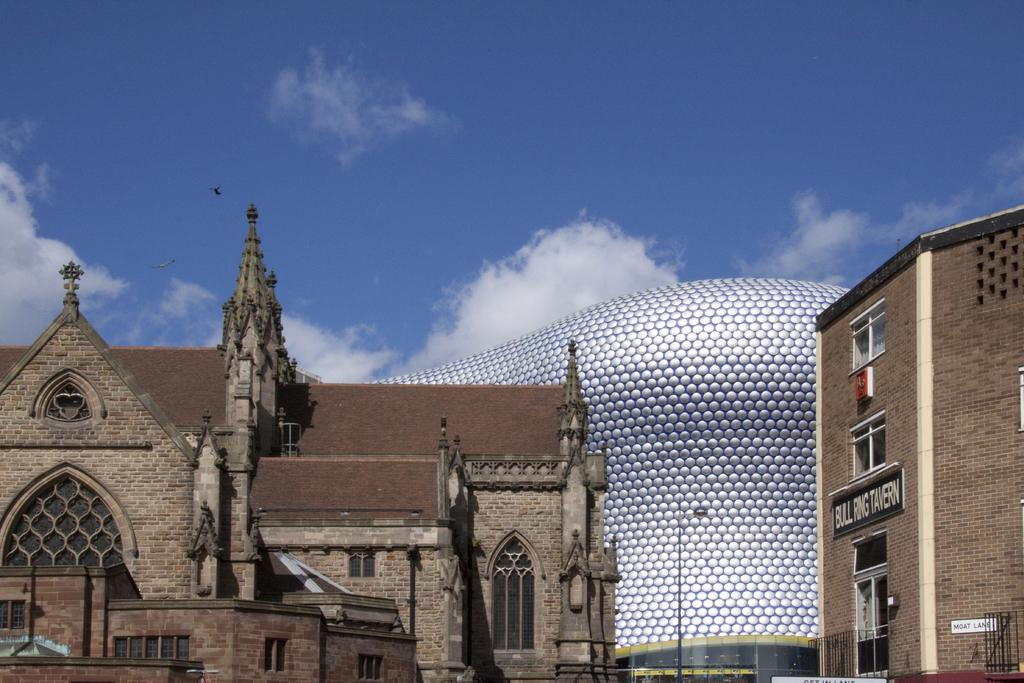What type of structures are present on the ground in the image? There are buildings on the ground in the image. What color is the sky in the background? The sky is blue in the background. Are there any visible weather phenomena in the sky? Yes, there are clouds visible in the sky. What type of flowers can be seen growing on the roofs of the buildings in the image? There are no flowers visible on the roofs of the buildings in the image. Can you tell me how the people in the image are saying good-bye to each other? There are no people present in the image, so it is not possible to observe any good-byes. 